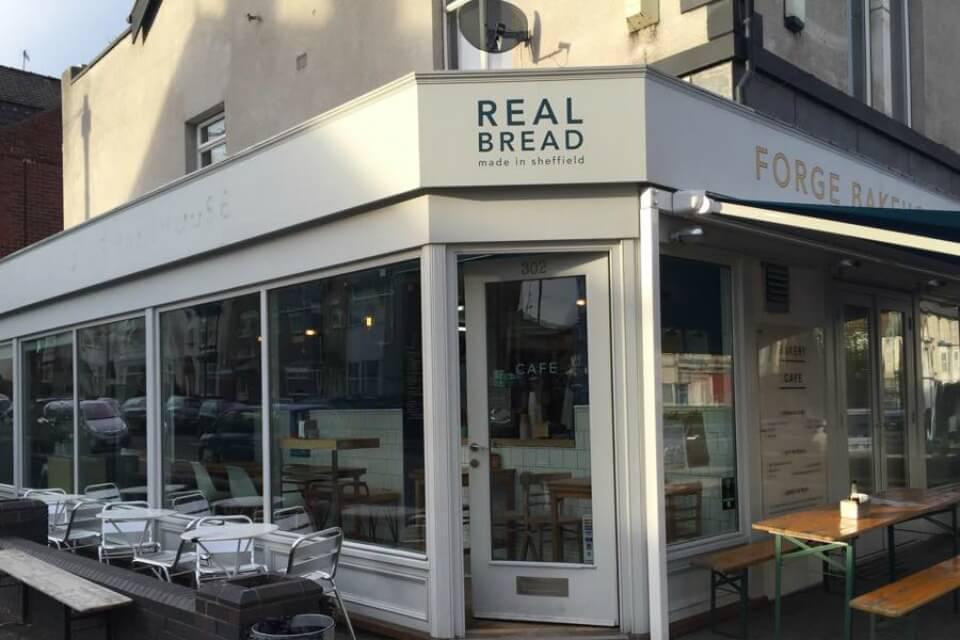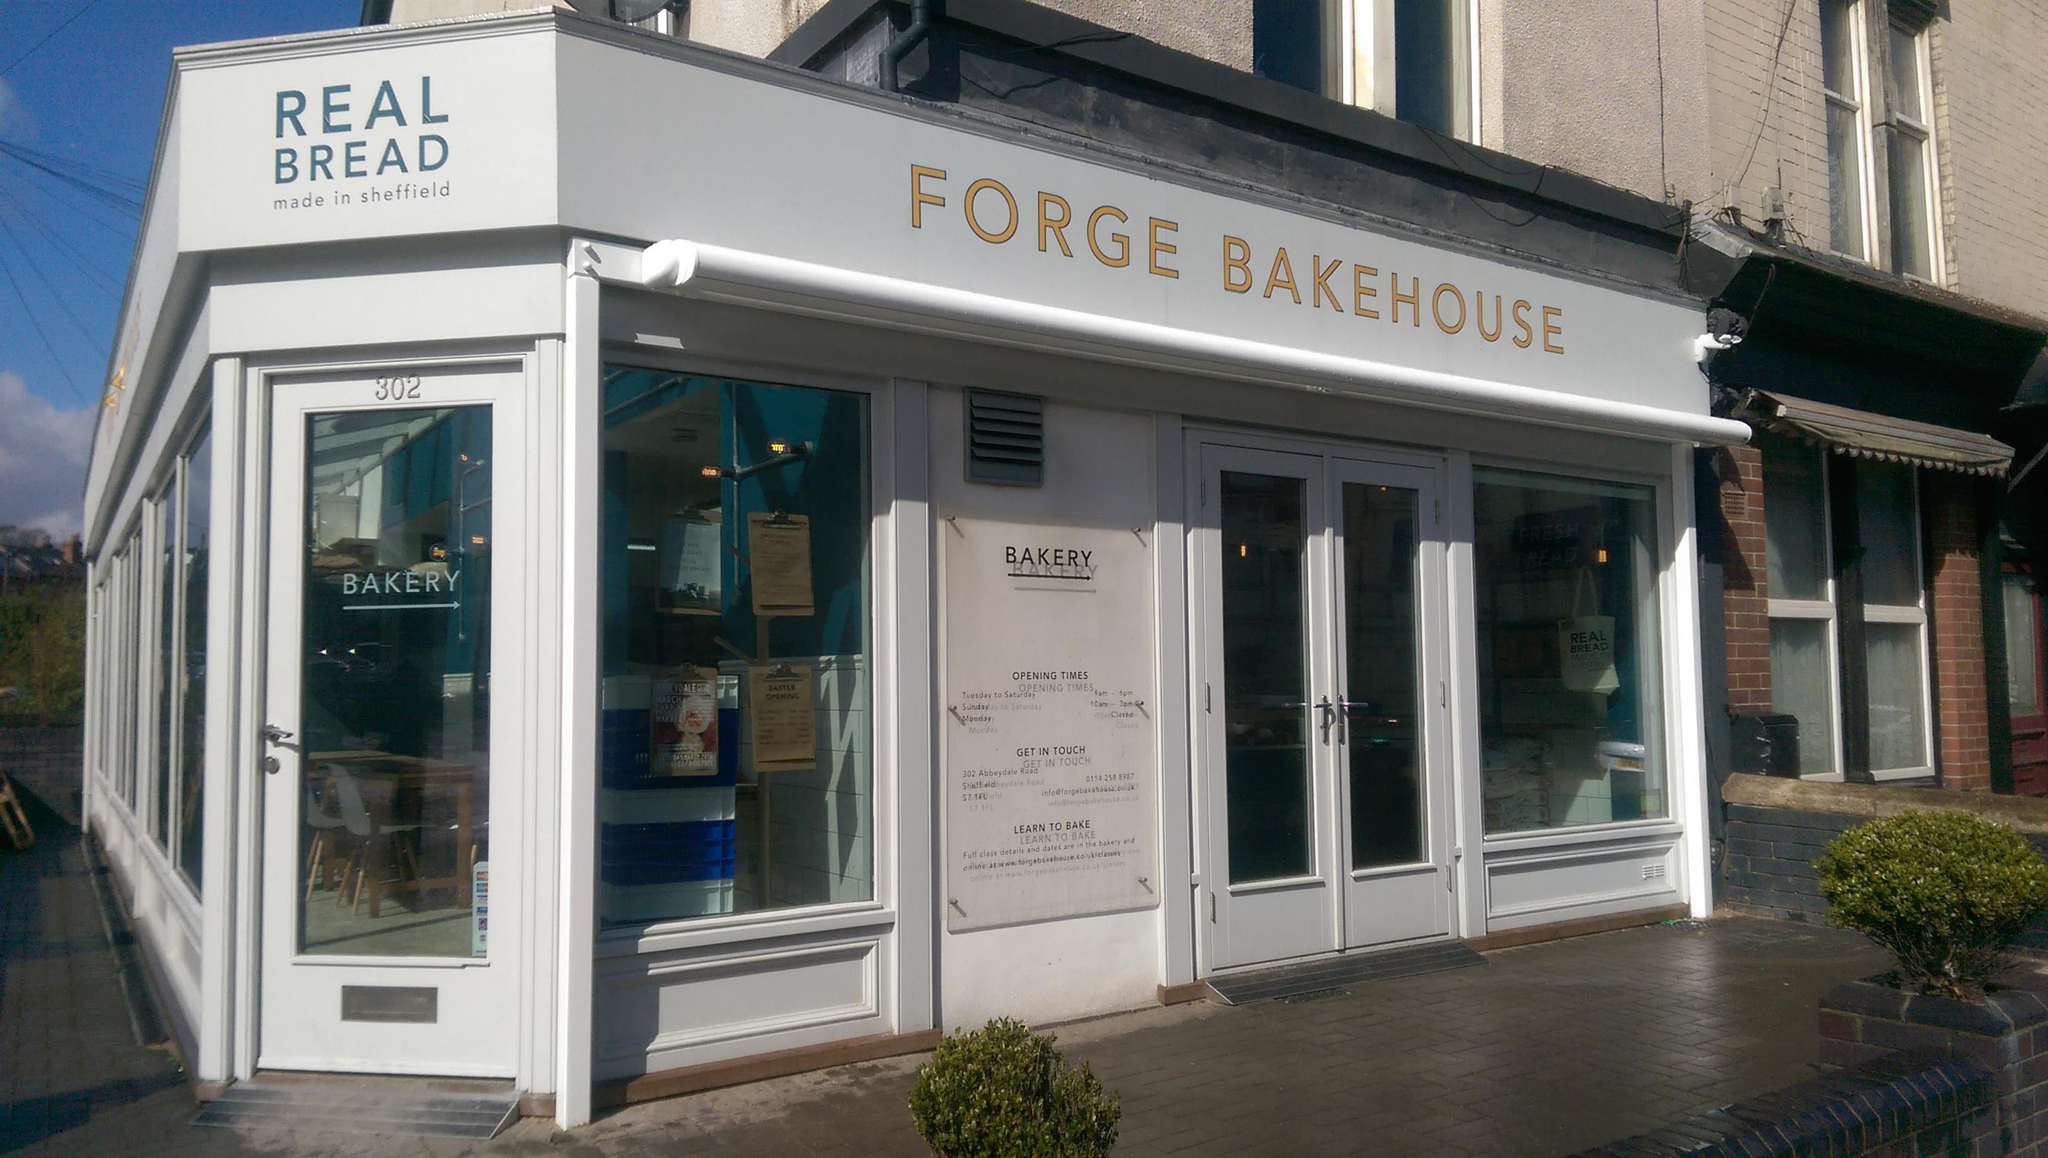The first image is the image on the left, the second image is the image on the right. Given the left and right images, does the statement "An outside view of the Forge Bakehouse." hold true? Answer yes or no. Yes. The first image is the image on the left, the second image is the image on the right. Given the left and right images, does the statement "Both images are of the outside of the store." hold true? Answer yes or no. Yes. 